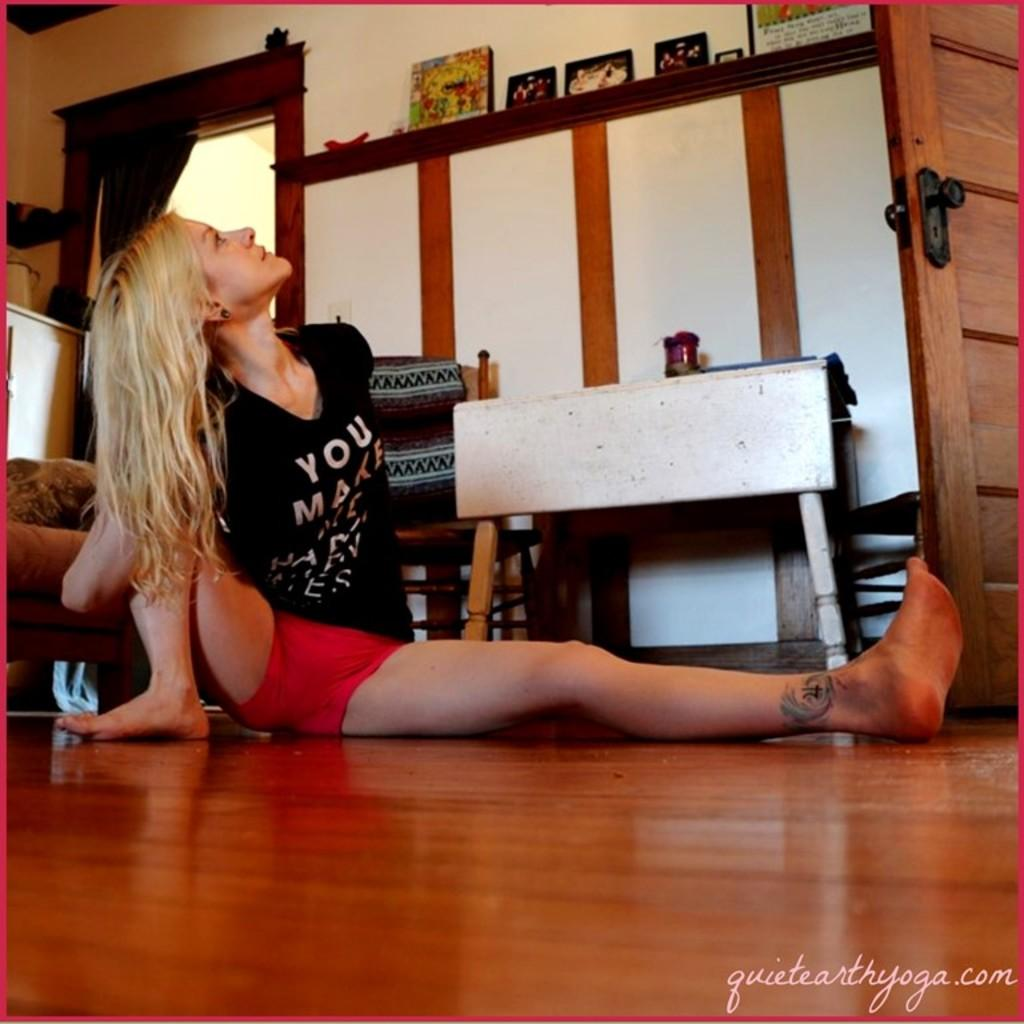<image>
Relay a brief, clear account of the picture shown. A woman stretches in a yoga pose on a hardwood floor in a photo for quietearthyoga.com. 